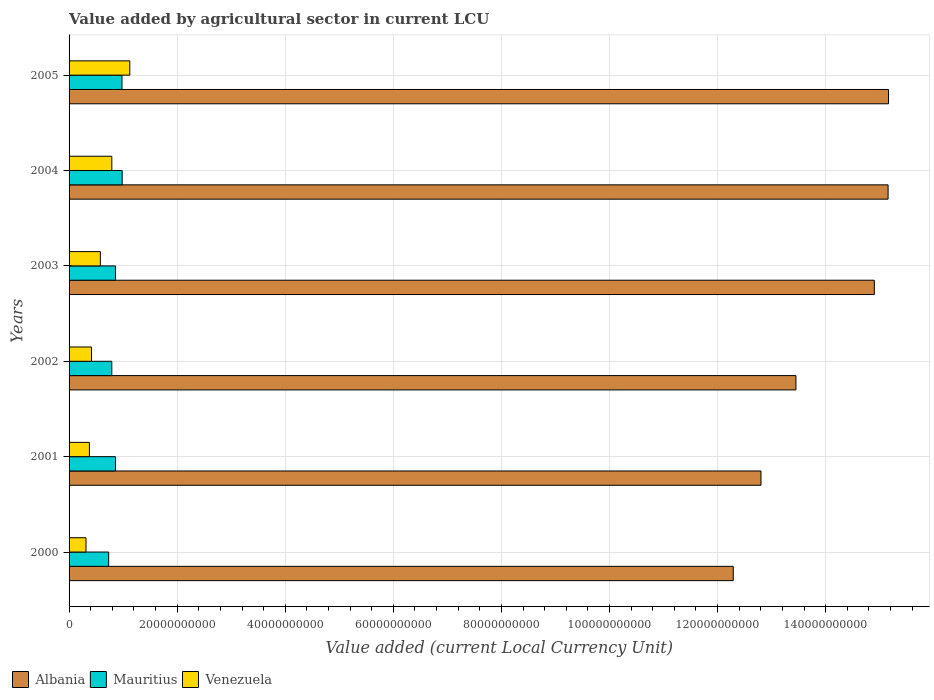How many different coloured bars are there?
Give a very brief answer. 3. How many groups of bars are there?
Your answer should be very brief. 6. How many bars are there on the 4th tick from the top?
Offer a very short reply. 3. How many bars are there on the 6th tick from the bottom?
Make the answer very short. 3. What is the label of the 5th group of bars from the top?
Your response must be concise. 2001. In how many cases, is the number of bars for a given year not equal to the number of legend labels?
Provide a short and direct response. 0. What is the value added by agricultural sector in Mauritius in 2005?
Keep it short and to the point. 9.79e+09. Across all years, what is the maximum value added by agricultural sector in Venezuela?
Provide a short and direct response. 1.12e+1. Across all years, what is the minimum value added by agricultural sector in Albania?
Keep it short and to the point. 1.23e+11. In which year was the value added by agricultural sector in Venezuela maximum?
Ensure brevity in your answer.  2005. What is the total value added by agricultural sector in Albania in the graph?
Offer a terse response. 8.38e+11. What is the difference between the value added by agricultural sector in Mauritius in 2000 and that in 2002?
Make the answer very short. -5.81e+08. What is the difference between the value added by agricultural sector in Venezuela in 2004 and the value added by agricultural sector in Albania in 2001?
Provide a succinct answer. -1.20e+11. What is the average value added by agricultural sector in Albania per year?
Offer a terse response. 1.40e+11. In the year 2004, what is the difference between the value added by agricultural sector in Albania and value added by agricultural sector in Venezuela?
Your answer should be compact. 1.44e+11. In how many years, is the value added by agricultural sector in Albania greater than 132000000000 LCU?
Ensure brevity in your answer.  4. What is the ratio of the value added by agricultural sector in Venezuela in 2001 to that in 2005?
Offer a terse response. 0.33. Is the value added by agricultural sector in Mauritius in 2000 less than that in 2004?
Your response must be concise. Yes. What is the difference between the highest and the second highest value added by agricultural sector in Mauritius?
Offer a terse response. 3.95e+07. What is the difference between the highest and the lowest value added by agricultural sector in Venezuela?
Give a very brief answer. 8.10e+09. Is the sum of the value added by agricultural sector in Venezuela in 2001 and 2003 greater than the maximum value added by agricultural sector in Mauritius across all years?
Your response must be concise. No. What does the 2nd bar from the top in 2003 represents?
Provide a succinct answer. Mauritius. What does the 2nd bar from the bottom in 2002 represents?
Offer a very short reply. Mauritius. Is it the case that in every year, the sum of the value added by agricultural sector in Mauritius and value added by agricultural sector in Venezuela is greater than the value added by agricultural sector in Albania?
Give a very brief answer. No. Are all the bars in the graph horizontal?
Your response must be concise. Yes. How many years are there in the graph?
Provide a short and direct response. 6. What is the difference between two consecutive major ticks on the X-axis?
Provide a succinct answer. 2.00e+1. Does the graph contain any zero values?
Your answer should be very brief. No. Does the graph contain grids?
Offer a terse response. Yes. How many legend labels are there?
Give a very brief answer. 3. What is the title of the graph?
Your response must be concise. Value added by agricultural sector in current LCU. What is the label or title of the X-axis?
Your answer should be compact. Value added (current Local Currency Unit). What is the Value added (current Local Currency Unit) of Albania in 2000?
Your answer should be compact. 1.23e+11. What is the Value added (current Local Currency Unit) in Mauritius in 2000?
Your answer should be compact. 7.33e+09. What is the Value added (current Local Currency Unit) of Venezuela in 2000?
Your response must be concise. 3.13e+09. What is the Value added (current Local Currency Unit) of Albania in 2001?
Your response must be concise. 1.28e+11. What is the Value added (current Local Currency Unit) of Mauritius in 2001?
Offer a terse response. 8.60e+09. What is the Value added (current Local Currency Unit) of Venezuela in 2001?
Your answer should be compact. 3.76e+09. What is the Value added (current Local Currency Unit) in Albania in 2002?
Offer a terse response. 1.35e+11. What is the Value added (current Local Currency Unit) in Mauritius in 2002?
Offer a terse response. 7.91e+09. What is the Value added (current Local Currency Unit) in Venezuela in 2002?
Your response must be concise. 4.15e+09. What is the Value added (current Local Currency Unit) of Albania in 2003?
Your answer should be very brief. 1.49e+11. What is the Value added (current Local Currency Unit) of Mauritius in 2003?
Your answer should be compact. 8.59e+09. What is the Value added (current Local Currency Unit) of Venezuela in 2003?
Provide a succinct answer. 5.79e+09. What is the Value added (current Local Currency Unit) of Albania in 2004?
Ensure brevity in your answer.  1.52e+11. What is the Value added (current Local Currency Unit) in Mauritius in 2004?
Give a very brief answer. 9.83e+09. What is the Value added (current Local Currency Unit) in Venezuela in 2004?
Keep it short and to the point. 7.91e+09. What is the Value added (current Local Currency Unit) of Albania in 2005?
Offer a very short reply. 1.52e+11. What is the Value added (current Local Currency Unit) in Mauritius in 2005?
Keep it short and to the point. 9.79e+09. What is the Value added (current Local Currency Unit) in Venezuela in 2005?
Offer a very short reply. 1.12e+1. Across all years, what is the maximum Value added (current Local Currency Unit) of Albania?
Your answer should be compact. 1.52e+11. Across all years, what is the maximum Value added (current Local Currency Unit) of Mauritius?
Your answer should be compact. 9.83e+09. Across all years, what is the maximum Value added (current Local Currency Unit) of Venezuela?
Keep it short and to the point. 1.12e+1. Across all years, what is the minimum Value added (current Local Currency Unit) of Albania?
Offer a very short reply. 1.23e+11. Across all years, what is the minimum Value added (current Local Currency Unit) in Mauritius?
Ensure brevity in your answer.  7.33e+09. Across all years, what is the minimum Value added (current Local Currency Unit) in Venezuela?
Your response must be concise. 3.13e+09. What is the total Value added (current Local Currency Unit) in Albania in the graph?
Your response must be concise. 8.38e+11. What is the total Value added (current Local Currency Unit) of Mauritius in the graph?
Provide a short and direct response. 5.20e+1. What is the total Value added (current Local Currency Unit) in Venezuela in the graph?
Give a very brief answer. 3.60e+1. What is the difference between the Value added (current Local Currency Unit) in Albania in 2000 and that in 2001?
Offer a terse response. -5.13e+09. What is the difference between the Value added (current Local Currency Unit) in Mauritius in 2000 and that in 2001?
Provide a short and direct response. -1.27e+09. What is the difference between the Value added (current Local Currency Unit) in Venezuela in 2000 and that in 2001?
Your response must be concise. -6.31e+08. What is the difference between the Value added (current Local Currency Unit) of Albania in 2000 and that in 2002?
Make the answer very short. -1.16e+1. What is the difference between the Value added (current Local Currency Unit) of Mauritius in 2000 and that in 2002?
Provide a short and direct response. -5.81e+08. What is the difference between the Value added (current Local Currency Unit) in Venezuela in 2000 and that in 2002?
Offer a terse response. -1.02e+09. What is the difference between the Value added (current Local Currency Unit) in Albania in 2000 and that in 2003?
Your answer should be compact. -2.61e+1. What is the difference between the Value added (current Local Currency Unit) in Mauritius in 2000 and that in 2003?
Ensure brevity in your answer.  -1.26e+09. What is the difference between the Value added (current Local Currency Unit) in Venezuela in 2000 and that in 2003?
Offer a very short reply. -2.66e+09. What is the difference between the Value added (current Local Currency Unit) of Albania in 2000 and that in 2004?
Your answer should be compact. -2.87e+1. What is the difference between the Value added (current Local Currency Unit) of Mauritius in 2000 and that in 2004?
Give a very brief answer. -2.50e+09. What is the difference between the Value added (current Local Currency Unit) of Venezuela in 2000 and that in 2004?
Keep it short and to the point. -4.78e+09. What is the difference between the Value added (current Local Currency Unit) of Albania in 2000 and that in 2005?
Offer a very short reply. -2.87e+1. What is the difference between the Value added (current Local Currency Unit) of Mauritius in 2000 and that in 2005?
Your answer should be compact. -2.46e+09. What is the difference between the Value added (current Local Currency Unit) in Venezuela in 2000 and that in 2005?
Ensure brevity in your answer.  -8.10e+09. What is the difference between the Value added (current Local Currency Unit) in Albania in 2001 and that in 2002?
Provide a short and direct response. -6.47e+09. What is the difference between the Value added (current Local Currency Unit) of Mauritius in 2001 and that in 2002?
Provide a short and direct response. 6.86e+08. What is the difference between the Value added (current Local Currency Unit) of Venezuela in 2001 and that in 2002?
Make the answer very short. -3.85e+08. What is the difference between the Value added (current Local Currency Unit) of Albania in 2001 and that in 2003?
Make the answer very short. -2.10e+1. What is the difference between the Value added (current Local Currency Unit) in Mauritius in 2001 and that in 2003?
Provide a succinct answer. 7.24e+06. What is the difference between the Value added (current Local Currency Unit) of Venezuela in 2001 and that in 2003?
Keep it short and to the point. -2.03e+09. What is the difference between the Value added (current Local Currency Unit) in Albania in 2001 and that in 2004?
Provide a succinct answer. -2.35e+1. What is the difference between the Value added (current Local Currency Unit) of Mauritius in 2001 and that in 2004?
Ensure brevity in your answer.  -1.23e+09. What is the difference between the Value added (current Local Currency Unit) in Venezuela in 2001 and that in 2004?
Your answer should be very brief. -4.15e+09. What is the difference between the Value added (current Local Currency Unit) in Albania in 2001 and that in 2005?
Your answer should be compact. -2.36e+1. What is the difference between the Value added (current Local Currency Unit) in Mauritius in 2001 and that in 2005?
Keep it short and to the point. -1.19e+09. What is the difference between the Value added (current Local Currency Unit) of Venezuela in 2001 and that in 2005?
Give a very brief answer. -7.47e+09. What is the difference between the Value added (current Local Currency Unit) of Albania in 2002 and that in 2003?
Keep it short and to the point. -1.45e+1. What is the difference between the Value added (current Local Currency Unit) of Mauritius in 2002 and that in 2003?
Offer a terse response. -6.79e+08. What is the difference between the Value added (current Local Currency Unit) of Venezuela in 2002 and that in 2003?
Provide a short and direct response. -1.64e+09. What is the difference between the Value added (current Local Currency Unit) in Albania in 2002 and that in 2004?
Provide a succinct answer. -1.71e+1. What is the difference between the Value added (current Local Currency Unit) of Mauritius in 2002 and that in 2004?
Your answer should be compact. -1.92e+09. What is the difference between the Value added (current Local Currency Unit) in Venezuela in 2002 and that in 2004?
Offer a very short reply. -3.76e+09. What is the difference between the Value added (current Local Currency Unit) in Albania in 2002 and that in 2005?
Provide a succinct answer. -1.71e+1. What is the difference between the Value added (current Local Currency Unit) in Mauritius in 2002 and that in 2005?
Ensure brevity in your answer.  -1.88e+09. What is the difference between the Value added (current Local Currency Unit) of Venezuela in 2002 and that in 2005?
Ensure brevity in your answer.  -7.09e+09. What is the difference between the Value added (current Local Currency Unit) in Albania in 2003 and that in 2004?
Your answer should be very brief. -2.55e+09. What is the difference between the Value added (current Local Currency Unit) in Mauritius in 2003 and that in 2004?
Keep it short and to the point. -1.24e+09. What is the difference between the Value added (current Local Currency Unit) of Venezuela in 2003 and that in 2004?
Offer a very short reply. -2.12e+09. What is the difference between the Value added (current Local Currency Unit) in Albania in 2003 and that in 2005?
Provide a short and direct response. -2.63e+09. What is the difference between the Value added (current Local Currency Unit) of Mauritius in 2003 and that in 2005?
Keep it short and to the point. -1.20e+09. What is the difference between the Value added (current Local Currency Unit) in Venezuela in 2003 and that in 2005?
Keep it short and to the point. -5.45e+09. What is the difference between the Value added (current Local Currency Unit) of Albania in 2004 and that in 2005?
Make the answer very short. -7.81e+07. What is the difference between the Value added (current Local Currency Unit) of Mauritius in 2004 and that in 2005?
Your response must be concise. 3.95e+07. What is the difference between the Value added (current Local Currency Unit) of Venezuela in 2004 and that in 2005?
Offer a terse response. -3.33e+09. What is the difference between the Value added (current Local Currency Unit) in Albania in 2000 and the Value added (current Local Currency Unit) in Mauritius in 2001?
Offer a very short reply. 1.14e+11. What is the difference between the Value added (current Local Currency Unit) of Albania in 2000 and the Value added (current Local Currency Unit) of Venezuela in 2001?
Your response must be concise. 1.19e+11. What is the difference between the Value added (current Local Currency Unit) of Mauritius in 2000 and the Value added (current Local Currency Unit) of Venezuela in 2001?
Ensure brevity in your answer.  3.56e+09. What is the difference between the Value added (current Local Currency Unit) of Albania in 2000 and the Value added (current Local Currency Unit) of Mauritius in 2002?
Your answer should be very brief. 1.15e+11. What is the difference between the Value added (current Local Currency Unit) of Albania in 2000 and the Value added (current Local Currency Unit) of Venezuela in 2002?
Offer a very short reply. 1.19e+11. What is the difference between the Value added (current Local Currency Unit) of Mauritius in 2000 and the Value added (current Local Currency Unit) of Venezuela in 2002?
Keep it short and to the point. 3.18e+09. What is the difference between the Value added (current Local Currency Unit) in Albania in 2000 and the Value added (current Local Currency Unit) in Mauritius in 2003?
Give a very brief answer. 1.14e+11. What is the difference between the Value added (current Local Currency Unit) of Albania in 2000 and the Value added (current Local Currency Unit) of Venezuela in 2003?
Your answer should be very brief. 1.17e+11. What is the difference between the Value added (current Local Currency Unit) in Mauritius in 2000 and the Value added (current Local Currency Unit) in Venezuela in 2003?
Your response must be concise. 1.54e+09. What is the difference between the Value added (current Local Currency Unit) of Albania in 2000 and the Value added (current Local Currency Unit) of Mauritius in 2004?
Your answer should be very brief. 1.13e+11. What is the difference between the Value added (current Local Currency Unit) of Albania in 2000 and the Value added (current Local Currency Unit) of Venezuela in 2004?
Give a very brief answer. 1.15e+11. What is the difference between the Value added (current Local Currency Unit) of Mauritius in 2000 and the Value added (current Local Currency Unit) of Venezuela in 2004?
Provide a succinct answer. -5.81e+08. What is the difference between the Value added (current Local Currency Unit) in Albania in 2000 and the Value added (current Local Currency Unit) in Mauritius in 2005?
Ensure brevity in your answer.  1.13e+11. What is the difference between the Value added (current Local Currency Unit) of Albania in 2000 and the Value added (current Local Currency Unit) of Venezuela in 2005?
Keep it short and to the point. 1.12e+11. What is the difference between the Value added (current Local Currency Unit) in Mauritius in 2000 and the Value added (current Local Currency Unit) in Venezuela in 2005?
Provide a succinct answer. -3.91e+09. What is the difference between the Value added (current Local Currency Unit) of Albania in 2001 and the Value added (current Local Currency Unit) of Mauritius in 2002?
Your answer should be very brief. 1.20e+11. What is the difference between the Value added (current Local Currency Unit) in Albania in 2001 and the Value added (current Local Currency Unit) in Venezuela in 2002?
Give a very brief answer. 1.24e+11. What is the difference between the Value added (current Local Currency Unit) in Mauritius in 2001 and the Value added (current Local Currency Unit) in Venezuela in 2002?
Your response must be concise. 4.45e+09. What is the difference between the Value added (current Local Currency Unit) in Albania in 2001 and the Value added (current Local Currency Unit) in Mauritius in 2003?
Provide a short and direct response. 1.19e+11. What is the difference between the Value added (current Local Currency Unit) of Albania in 2001 and the Value added (current Local Currency Unit) of Venezuela in 2003?
Provide a succinct answer. 1.22e+11. What is the difference between the Value added (current Local Currency Unit) of Mauritius in 2001 and the Value added (current Local Currency Unit) of Venezuela in 2003?
Your response must be concise. 2.81e+09. What is the difference between the Value added (current Local Currency Unit) of Albania in 2001 and the Value added (current Local Currency Unit) of Mauritius in 2004?
Offer a terse response. 1.18e+11. What is the difference between the Value added (current Local Currency Unit) of Albania in 2001 and the Value added (current Local Currency Unit) of Venezuela in 2004?
Your response must be concise. 1.20e+11. What is the difference between the Value added (current Local Currency Unit) in Mauritius in 2001 and the Value added (current Local Currency Unit) in Venezuela in 2004?
Make the answer very short. 6.86e+08. What is the difference between the Value added (current Local Currency Unit) of Albania in 2001 and the Value added (current Local Currency Unit) of Mauritius in 2005?
Provide a succinct answer. 1.18e+11. What is the difference between the Value added (current Local Currency Unit) in Albania in 2001 and the Value added (current Local Currency Unit) in Venezuela in 2005?
Ensure brevity in your answer.  1.17e+11. What is the difference between the Value added (current Local Currency Unit) in Mauritius in 2001 and the Value added (current Local Currency Unit) in Venezuela in 2005?
Ensure brevity in your answer.  -2.64e+09. What is the difference between the Value added (current Local Currency Unit) in Albania in 2002 and the Value added (current Local Currency Unit) in Mauritius in 2003?
Your answer should be compact. 1.26e+11. What is the difference between the Value added (current Local Currency Unit) of Albania in 2002 and the Value added (current Local Currency Unit) of Venezuela in 2003?
Offer a terse response. 1.29e+11. What is the difference between the Value added (current Local Currency Unit) of Mauritius in 2002 and the Value added (current Local Currency Unit) of Venezuela in 2003?
Make the answer very short. 2.12e+09. What is the difference between the Value added (current Local Currency Unit) in Albania in 2002 and the Value added (current Local Currency Unit) in Mauritius in 2004?
Make the answer very short. 1.25e+11. What is the difference between the Value added (current Local Currency Unit) in Albania in 2002 and the Value added (current Local Currency Unit) in Venezuela in 2004?
Provide a succinct answer. 1.27e+11. What is the difference between the Value added (current Local Currency Unit) in Mauritius in 2002 and the Value added (current Local Currency Unit) in Venezuela in 2004?
Provide a short and direct response. 3.44e+04. What is the difference between the Value added (current Local Currency Unit) in Albania in 2002 and the Value added (current Local Currency Unit) in Mauritius in 2005?
Your response must be concise. 1.25e+11. What is the difference between the Value added (current Local Currency Unit) of Albania in 2002 and the Value added (current Local Currency Unit) of Venezuela in 2005?
Ensure brevity in your answer.  1.23e+11. What is the difference between the Value added (current Local Currency Unit) of Mauritius in 2002 and the Value added (current Local Currency Unit) of Venezuela in 2005?
Your answer should be very brief. -3.33e+09. What is the difference between the Value added (current Local Currency Unit) of Albania in 2003 and the Value added (current Local Currency Unit) of Mauritius in 2004?
Ensure brevity in your answer.  1.39e+11. What is the difference between the Value added (current Local Currency Unit) in Albania in 2003 and the Value added (current Local Currency Unit) in Venezuela in 2004?
Give a very brief answer. 1.41e+11. What is the difference between the Value added (current Local Currency Unit) in Mauritius in 2003 and the Value added (current Local Currency Unit) in Venezuela in 2004?
Make the answer very short. 6.79e+08. What is the difference between the Value added (current Local Currency Unit) of Albania in 2003 and the Value added (current Local Currency Unit) of Mauritius in 2005?
Provide a succinct answer. 1.39e+11. What is the difference between the Value added (current Local Currency Unit) in Albania in 2003 and the Value added (current Local Currency Unit) in Venezuela in 2005?
Ensure brevity in your answer.  1.38e+11. What is the difference between the Value added (current Local Currency Unit) of Mauritius in 2003 and the Value added (current Local Currency Unit) of Venezuela in 2005?
Provide a short and direct response. -2.65e+09. What is the difference between the Value added (current Local Currency Unit) in Albania in 2004 and the Value added (current Local Currency Unit) in Mauritius in 2005?
Make the answer very short. 1.42e+11. What is the difference between the Value added (current Local Currency Unit) of Albania in 2004 and the Value added (current Local Currency Unit) of Venezuela in 2005?
Keep it short and to the point. 1.40e+11. What is the difference between the Value added (current Local Currency Unit) of Mauritius in 2004 and the Value added (current Local Currency Unit) of Venezuela in 2005?
Offer a very short reply. -1.41e+09. What is the average Value added (current Local Currency Unit) in Albania per year?
Ensure brevity in your answer.  1.40e+11. What is the average Value added (current Local Currency Unit) of Mauritius per year?
Your answer should be compact. 8.67e+09. What is the average Value added (current Local Currency Unit) in Venezuela per year?
Offer a very short reply. 6.00e+09. In the year 2000, what is the difference between the Value added (current Local Currency Unit) in Albania and Value added (current Local Currency Unit) in Mauritius?
Offer a very short reply. 1.16e+11. In the year 2000, what is the difference between the Value added (current Local Currency Unit) in Albania and Value added (current Local Currency Unit) in Venezuela?
Offer a very short reply. 1.20e+11. In the year 2000, what is the difference between the Value added (current Local Currency Unit) in Mauritius and Value added (current Local Currency Unit) in Venezuela?
Provide a short and direct response. 4.20e+09. In the year 2001, what is the difference between the Value added (current Local Currency Unit) of Albania and Value added (current Local Currency Unit) of Mauritius?
Offer a very short reply. 1.19e+11. In the year 2001, what is the difference between the Value added (current Local Currency Unit) in Albania and Value added (current Local Currency Unit) in Venezuela?
Keep it short and to the point. 1.24e+11. In the year 2001, what is the difference between the Value added (current Local Currency Unit) in Mauritius and Value added (current Local Currency Unit) in Venezuela?
Make the answer very short. 4.83e+09. In the year 2002, what is the difference between the Value added (current Local Currency Unit) of Albania and Value added (current Local Currency Unit) of Mauritius?
Provide a succinct answer. 1.27e+11. In the year 2002, what is the difference between the Value added (current Local Currency Unit) of Albania and Value added (current Local Currency Unit) of Venezuela?
Give a very brief answer. 1.30e+11. In the year 2002, what is the difference between the Value added (current Local Currency Unit) in Mauritius and Value added (current Local Currency Unit) in Venezuela?
Make the answer very short. 3.76e+09. In the year 2003, what is the difference between the Value added (current Local Currency Unit) in Albania and Value added (current Local Currency Unit) in Mauritius?
Offer a very short reply. 1.40e+11. In the year 2003, what is the difference between the Value added (current Local Currency Unit) in Albania and Value added (current Local Currency Unit) in Venezuela?
Your answer should be compact. 1.43e+11. In the year 2003, what is the difference between the Value added (current Local Currency Unit) of Mauritius and Value added (current Local Currency Unit) of Venezuela?
Keep it short and to the point. 2.80e+09. In the year 2004, what is the difference between the Value added (current Local Currency Unit) in Albania and Value added (current Local Currency Unit) in Mauritius?
Your answer should be very brief. 1.42e+11. In the year 2004, what is the difference between the Value added (current Local Currency Unit) in Albania and Value added (current Local Currency Unit) in Venezuela?
Provide a short and direct response. 1.44e+11. In the year 2004, what is the difference between the Value added (current Local Currency Unit) in Mauritius and Value added (current Local Currency Unit) in Venezuela?
Ensure brevity in your answer.  1.92e+09. In the year 2005, what is the difference between the Value added (current Local Currency Unit) of Albania and Value added (current Local Currency Unit) of Mauritius?
Your response must be concise. 1.42e+11. In the year 2005, what is the difference between the Value added (current Local Currency Unit) in Albania and Value added (current Local Currency Unit) in Venezuela?
Ensure brevity in your answer.  1.40e+11. In the year 2005, what is the difference between the Value added (current Local Currency Unit) in Mauritius and Value added (current Local Currency Unit) in Venezuela?
Provide a succinct answer. -1.45e+09. What is the ratio of the Value added (current Local Currency Unit) of Albania in 2000 to that in 2001?
Your response must be concise. 0.96. What is the ratio of the Value added (current Local Currency Unit) of Mauritius in 2000 to that in 2001?
Make the answer very short. 0.85. What is the ratio of the Value added (current Local Currency Unit) in Venezuela in 2000 to that in 2001?
Keep it short and to the point. 0.83. What is the ratio of the Value added (current Local Currency Unit) of Albania in 2000 to that in 2002?
Your answer should be compact. 0.91. What is the ratio of the Value added (current Local Currency Unit) of Mauritius in 2000 to that in 2002?
Ensure brevity in your answer.  0.93. What is the ratio of the Value added (current Local Currency Unit) of Venezuela in 2000 to that in 2002?
Your answer should be compact. 0.76. What is the ratio of the Value added (current Local Currency Unit) in Albania in 2000 to that in 2003?
Make the answer very short. 0.82. What is the ratio of the Value added (current Local Currency Unit) of Mauritius in 2000 to that in 2003?
Your answer should be compact. 0.85. What is the ratio of the Value added (current Local Currency Unit) of Venezuela in 2000 to that in 2003?
Keep it short and to the point. 0.54. What is the ratio of the Value added (current Local Currency Unit) of Albania in 2000 to that in 2004?
Your answer should be very brief. 0.81. What is the ratio of the Value added (current Local Currency Unit) of Mauritius in 2000 to that in 2004?
Offer a very short reply. 0.75. What is the ratio of the Value added (current Local Currency Unit) in Venezuela in 2000 to that in 2004?
Make the answer very short. 0.4. What is the ratio of the Value added (current Local Currency Unit) in Albania in 2000 to that in 2005?
Provide a succinct answer. 0.81. What is the ratio of the Value added (current Local Currency Unit) of Mauritius in 2000 to that in 2005?
Your answer should be compact. 0.75. What is the ratio of the Value added (current Local Currency Unit) in Venezuela in 2000 to that in 2005?
Your answer should be very brief. 0.28. What is the ratio of the Value added (current Local Currency Unit) in Albania in 2001 to that in 2002?
Ensure brevity in your answer.  0.95. What is the ratio of the Value added (current Local Currency Unit) in Mauritius in 2001 to that in 2002?
Provide a succinct answer. 1.09. What is the ratio of the Value added (current Local Currency Unit) of Venezuela in 2001 to that in 2002?
Provide a succinct answer. 0.91. What is the ratio of the Value added (current Local Currency Unit) of Albania in 2001 to that in 2003?
Give a very brief answer. 0.86. What is the ratio of the Value added (current Local Currency Unit) of Mauritius in 2001 to that in 2003?
Provide a short and direct response. 1. What is the ratio of the Value added (current Local Currency Unit) of Venezuela in 2001 to that in 2003?
Keep it short and to the point. 0.65. What is the ratio of the Value added (current Local Currency Unit) in Albania in 2001 to that in 2004?
Give a very brief answer. 0.84. What is the ratio of the Value added (current Local Currency Unit) of Mauritius in 2001 to that in 2004?
Make the answer very short. 0.87. What is the ratio of the Value added (current Local Currency Unit) in Venezuela in 2001 to that in 2004?
Ensure brevity in your answer.  0.48. What is the ratio of the Value added (current Local Currency Unit) in Albania in 2001 to that in 2005?
Your answer should be compact. 0.84. What is the ratio of the Value added (current Local Currency Unit) of Mauritius in 2001 to that in 2005?
Your answer should be very brief. 0.88. What is the ratio of the Value added (current Local Currency Unit) in Venezuela in 2001 to that in 2005?
Provide a succinct answer. 0.34. What is the ratio of the Value added (current Local Currency Unit) of Albania in 2002 to that in 2003?
Provide a short and direct response. 0.9. What is the ratio of the Value added (current Local Currency Unit) in Mauritius in 2002 to that in 2003?
Offer a terse response. 0.92. What is the ratio of the Value added (current Local Currency Unit) in Venezuela in 2002 to that in 2003?
Provide a short and direct response. 0.72. What is the ratio of the Value added (current Local Currency Unit) of Albania in 2002 to that in 2004?
Provide a short and direct response. 0.89. What is the ratio of the Value added (current Local Currency Unit) of Mauritius in 2002 to that in 2004?
Offer a very short reply. 0.8. What is the ratio of the Value added (current Local Currency Unit) of Venezuela in 2002 to that in 2004?
Ensure brevity in your answer.  0.52. What is the ratio of the Value added (current Local Currency Unit) of Albania in 2002 to that in 2005?
Your answer should be very brief. 0.89. What is the ratio of the Value added (current Local Currency Unit) in Mauritius in 2002 to that in 2005?
Provide a succinct answer. 0.81. What is the ratio of the Value added (current Local Currency Unit) of Venezuela in 2002 to that in 2005?
Offer a terse response. 0.37. What is the ratio of the Value added (current Local Currency Unit) in Albania in 2003 to that in 2004?
Provide a short and direct response. 0.98. What is the ratio of the Value added (current Local Currency Unit) of Mauritius in 2003 to that in 2004?
Your answer should be very brief. 0.87. What is the ratio of the Value added (current Local Currency Unit) of Venezuela in 2003 to that in 2004?
Your response must be concise. 0.73. What is the ratio of the Value added (current Local Currency Unit) in Albania in 2003 to that in 2005?
Provide a succinct answer. 0.98. What is the ratio of the Value added (current Local Currency Unit) in Mauritius in 2003 to that in 2005?
Keep it short and to the point. 0.88. What is the ratio of the Value added (current Local Currency Unit) in Venezuela in 2003 to that in 2005?
Provide a succinct answer. 0.52. What is the ratio of the Value added (current Local Currency Unit) of Venezuela in 2004 to that in 2005?
Your answer should be very brief. 0.7. What is the difference between the highest and the second highest Value added (current Local Currency Unit) in Albania?
Keep it short and to the point. 7.81e+07. What is the difference between the highest and the second highest Value added (current Local Currency Unit) of Mauritius?
Your answer should be compact. 3.95e+07. What is the difference between the highest and the second highest Value added (current Local Currency Unit) in Venezuela?
Make the answer very short. 3.33e+09. What is the difference between the highest and the lowest Value added (current Local Currency Unit) of Albania?
Keep it short and to the point. 2.87e+1. What is the difference between the highest and the lowest Value added (current Local Currency Unit) of Mauritius?
Ensure brevity in your answer.  2.50e+09. What is the difference between the highest and the lowest Value added (current Local Currency Unit) in Venezuela?
Your response must be concise. 8.10e+09. 